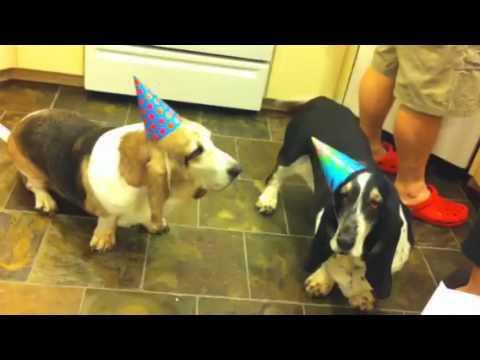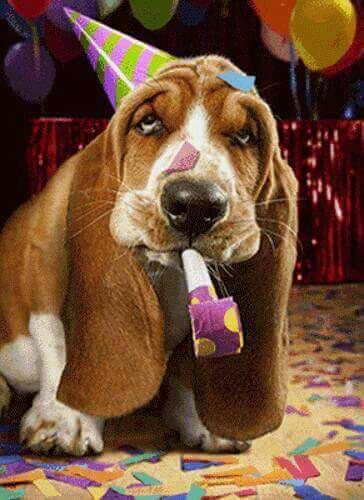The first image is the image on the left, the second image is the image on the right. Examine the images to the left and right. Is the description "One of the dogs is lying on a couch." accurate? Answer yes or no. No. The first image is the image on the left, the second image is the image on the right. For the images shown, is this caption "There are two basset hounds facing forward in both images." true? Answer yes or no. No. 